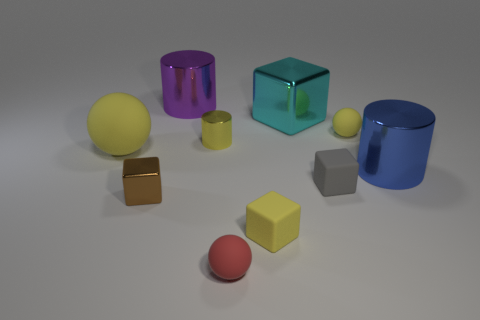Do the large ball and the tiny cylinder have the same color?
Offer a very short reply. Yes. There is a small cylinder that is the same color as the large ball; what is it made of?
Ensure brevity in your answer.  Metal. Do the large yellow thing and the big cylinder that is on the right side of the small yellow cube have the same material?
Provide a short and direct response. No. The small matte thing behind the rubber ball that is left of the large cylinder that is left of the large blue cylinder is what color?
Offer a terse response. Yellow. There is a small metal cylinder; does it have the same color as the small rubber cube in front of the brown object?
Provide a succinct answer. Yes. The large metal block is what color?
Keep it short and to the point. Cyan. There is a large shiny thing to the left of the small sphere that is to the left of the tiny rubber ball that is behind the brown metallic block; what shape is it?
Offer a terse response. Cylinder. What number of other objects are there of the same color as the tiny metal cylinder?
Your answer should be very brief. 3. Is the number of shiny objects in front of the blue metallic thing greater than the number of purple cylinders to the left of the big matte thing?
Offer a very short reply. Yes. There is a small gray object; are there any metallic things in front of it?
Ensure brevity in your answer.  Yes. 